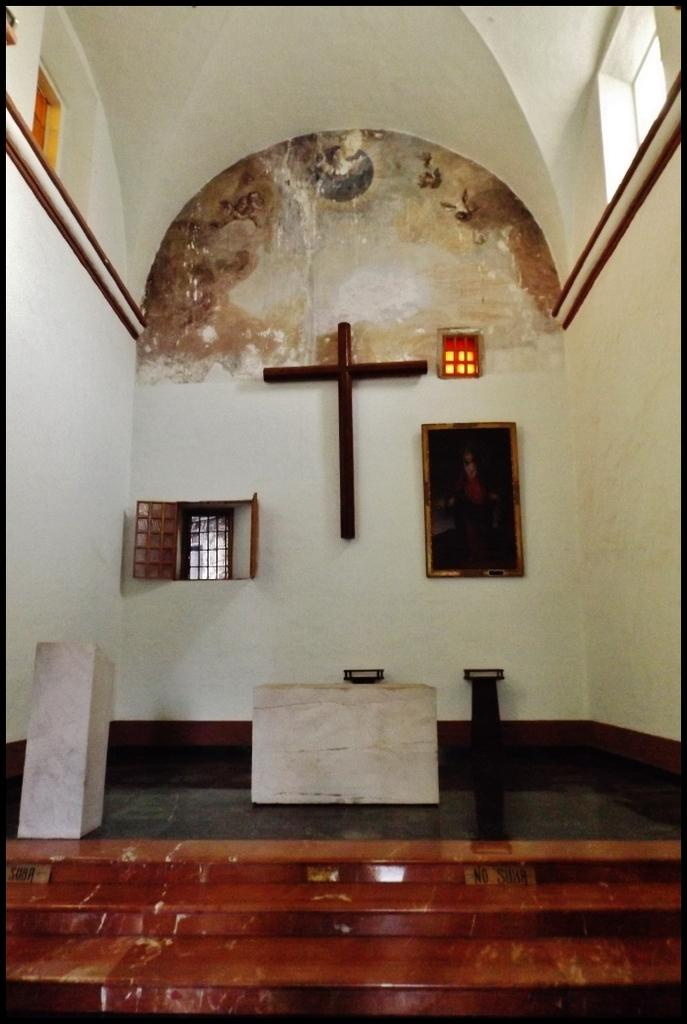What type of architectural feature is present in the image? There are steps in the image. What surface can be seen beneath the steps? There is a floor visible in the image. What structure is present in the image for presentations or speeches? There is a podium in the image. What can be seen in the image that might be used to hold or display items? There are objects in the image. What religious symbol is present in the image? There is a cross symbol in the image. What is on the wall in the image that might frame a picture or artwork? There is a frame on the wall in the image. What allows natural light to enter the space in the image? There are windows in the image. What type of store is depicted in the image? There is no store present in the image; it features steps, a floor, a podium, objects, a cross symbol, a frame on the wall, and windows. 